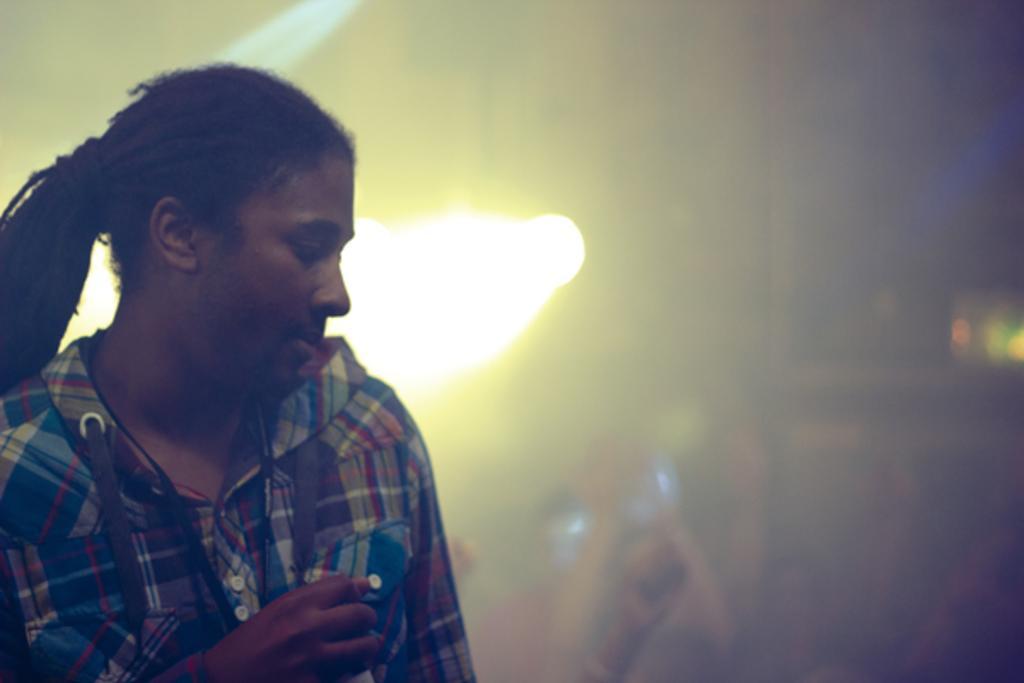Can you describe this image briefly? In this image we can see a person wearing shirt on the left side of the image. The background of the image is blurred, where we can see the light here. 